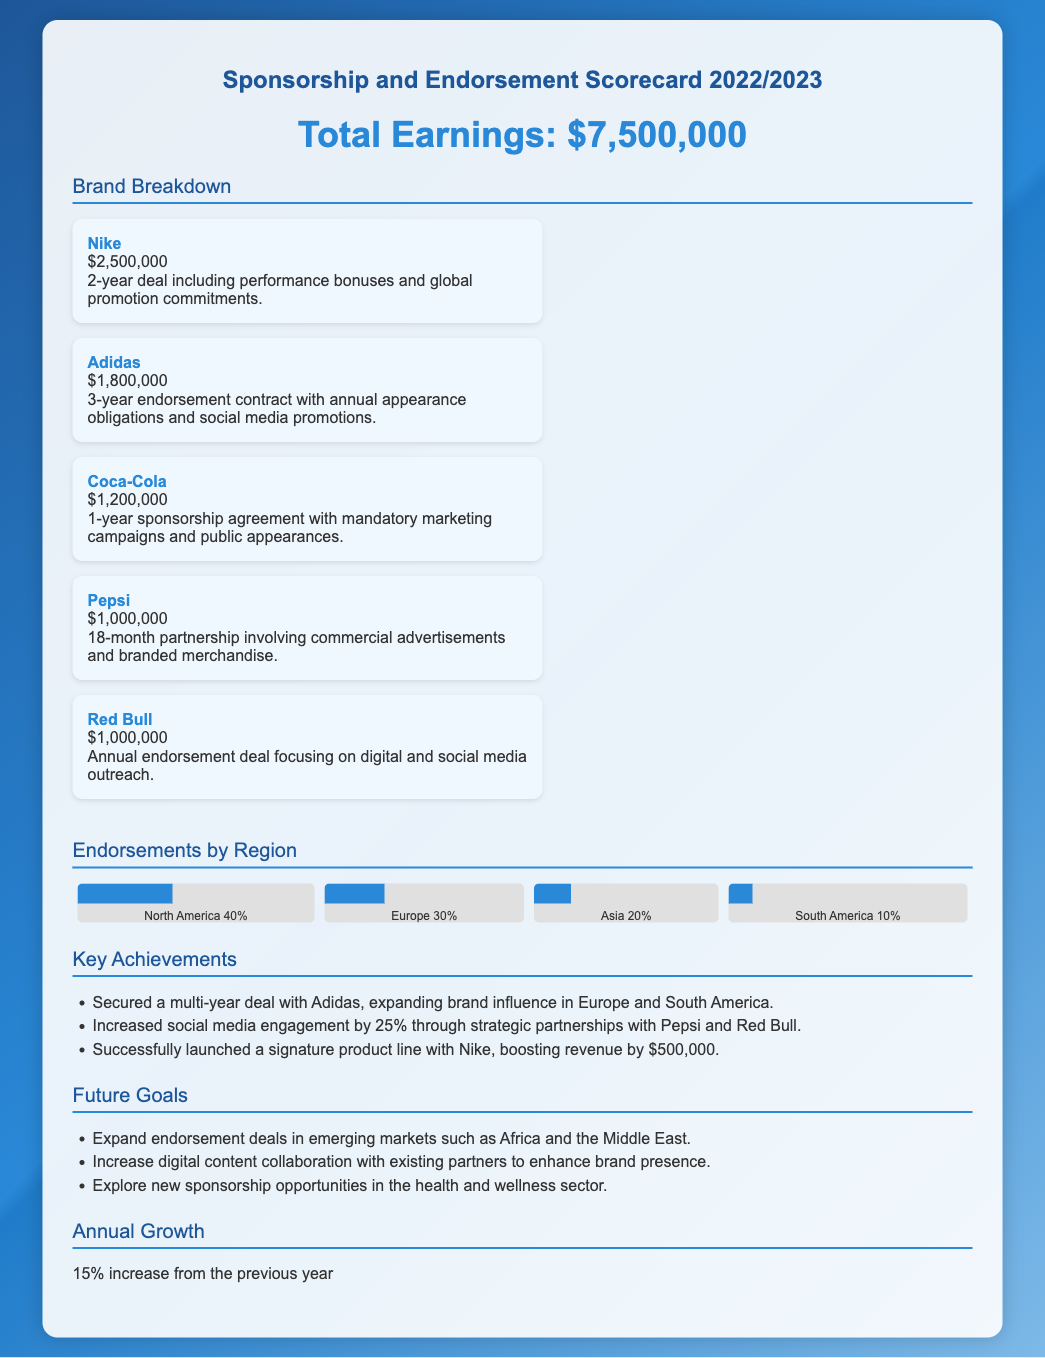What is the total earnings? The total earnings are provided prominently in the document and listed as $7,500,000.
Answer: $7,500,000 Which brand has the highest endorsement? The brand with the highest endorsement earnings is clearly stated in the brand breakdown section as Nike with $2,500,000.
Answer: Nike What is the duration of the contract with Coca-Cola? The duration of the contract with Coca-Cola is specified in the brand breakdown as a 1-year sponsorship agreement.
Answer: 1-year What percentage of total earnings comes from North America? The document provides a breakdown of endorsements by region, indicating that North America accounts for 40% of the earnings.
Answer: 40% What was the annual growth percentage reported? The document explicitly states that the annual growth is a 15% increase from the previous year.
Answer: 15% How much is earned from the partnership with Adidas? The document details the earnings from the partnership with Adidas as $1,800,000.
Answer: $1,800,000 What are the future goals mentioned in the document? The document outlines several future goals, one of which is to expand endorsement deals in emerging markets, specifically including Africa and the Middle East.
Answer: Expand endorsement deals in emerging markets How many brands are listed in the brand breakdown? The scorecard lists a total of five brands in the brand breakdown section, specifically listed.
Answer: Five brands Which brand is associated with an annual endorsement deal? The document notes that Red Bull is associated with an annual endorsement deal focusing on digital and social media outreach.
Answer: Red Bull 